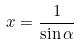Convert formula to latex. <formula><loc_0><loc_0><loc_500><loc_500>x = \frac { 1 } { \sin \alpha }</formula> 